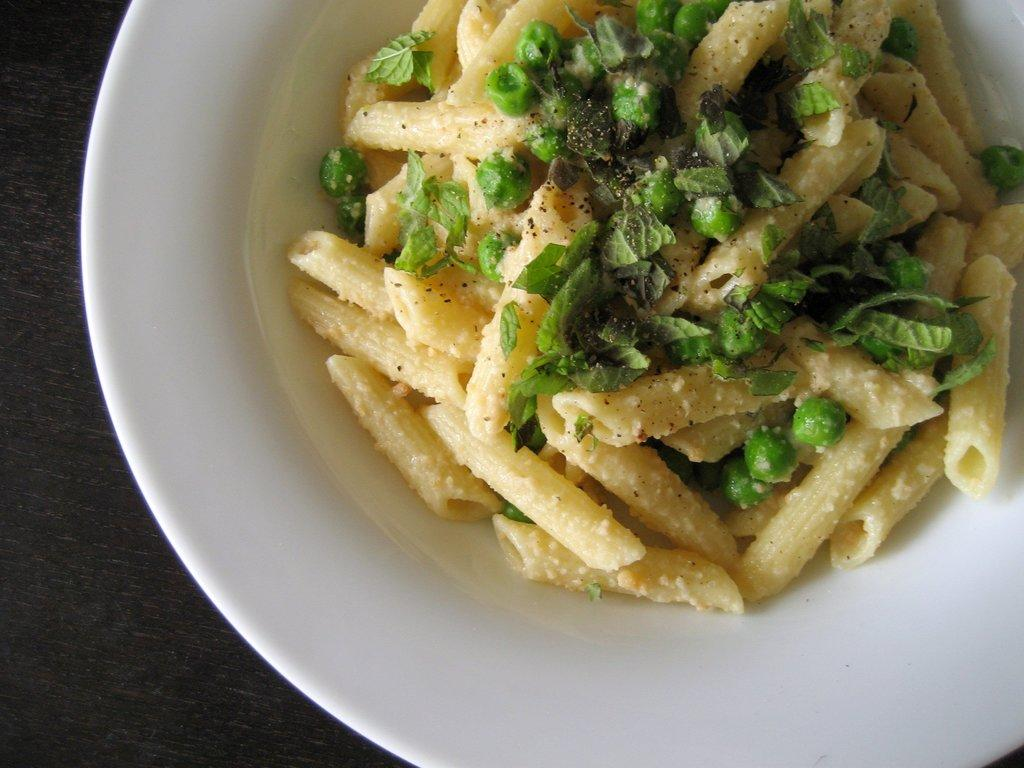What is in the bowl that is visible in the image? There is a bowl with food in the image. Where is the bowl located in the image? The bowl is placed on an object that looks like a table. What type of store can be seen in the background of the image? There is no store visible in the image; it only shows a bowl with food on a table-like object. 